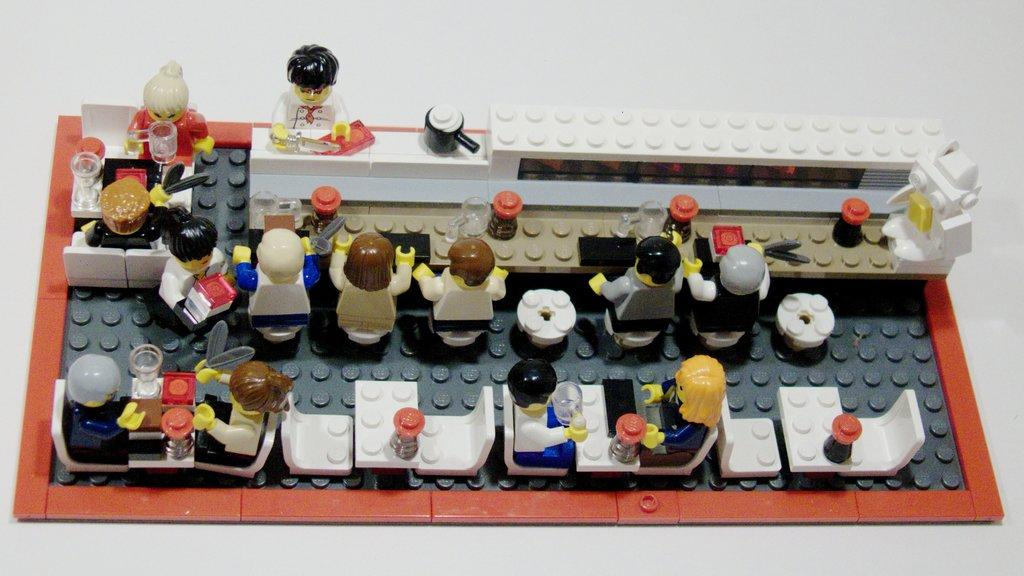What is the main subject of the image? There is a group of dolls in the image. Where are the dolls placed? The dolls are placed on a surface. What other toys can be seen in the background of the image? There are Lego toys in the background of the image. What types of containers are present in the background of the image? There are jars and mugs in the background of the image. What type of soda is being poured into the mugs in the image? There is no soda present in the image; it only features dolls, Lego toys, jars, and mugs. How does the feeling of the dolls change throughout the day in the image? The image does not depict any emotions or feelings of the dolls, as they are inanimate objects. 